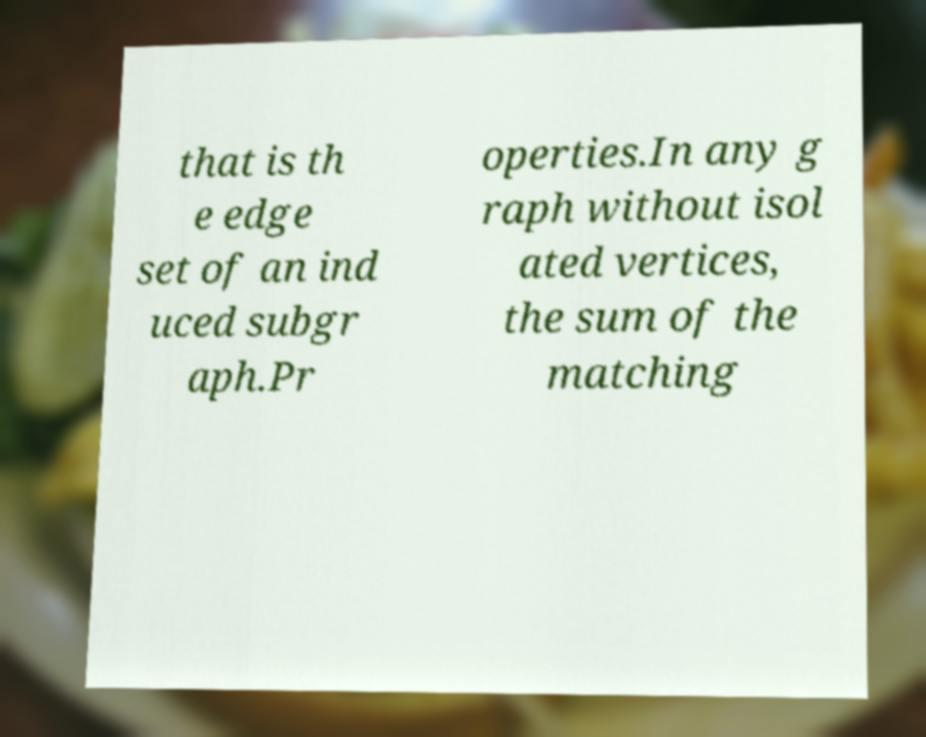Can you read and provide the text displayed in the image?This photo seems to have some interesting text. Can you extract and type it out for me? that is th e edge set of an ind uced subgr aph.Pr operties.In any g raph without isol ated vertices, the sum of the matching 